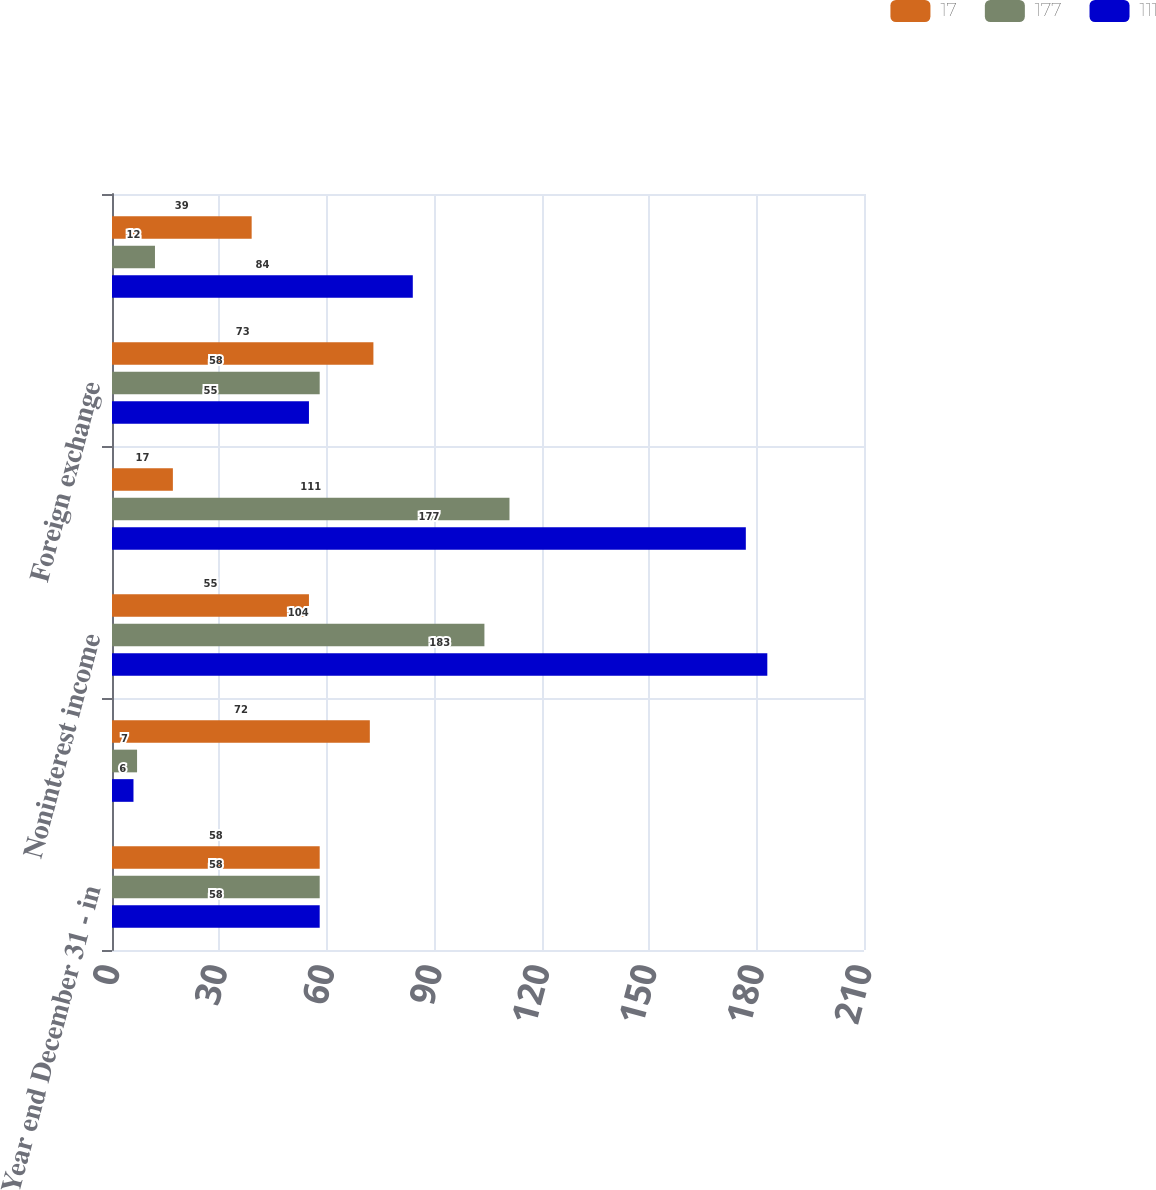Convert chart to OTSL. <chart><loc_0><loc_0><loc_500><loc_500><stacked_bar_chart><ecel><fcel>Year end December 31 - in<fcel>Net interest income (expense)<fcel>Noninterest income<fcel>Total trading revenue<fcel>Foreign exchange<fcel>Financial derivatives<nl><fcel>17<fcel>58<fcel>72<fcel>55<fcel>17<fcel>73<fcel>39<nl><fcel>177<fcel>58<fcel>7<fcel>104<fcel>111<fcel>58<fcel>12<nl><fcel>111<fcel>58<fcel>6<fcel>183<fcel>177<fcel>55<fcel>84<nl></chart> 